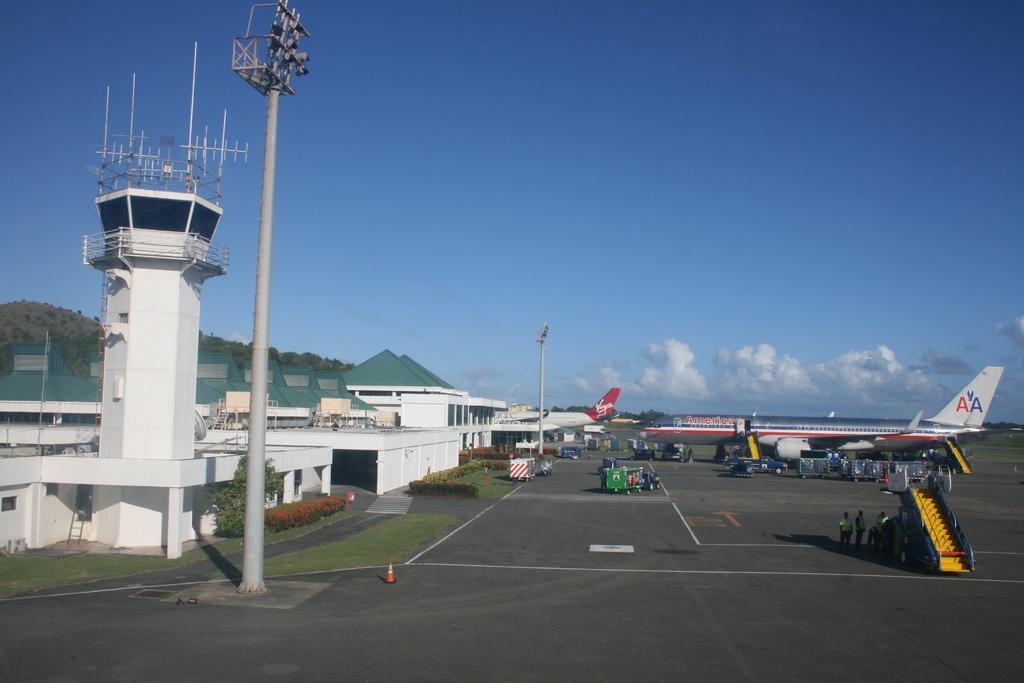What is the brand on the tail of the airplane?
Give a very brief answer. Aa. What is written on the fuselage?
Your answer should be compact. American. 